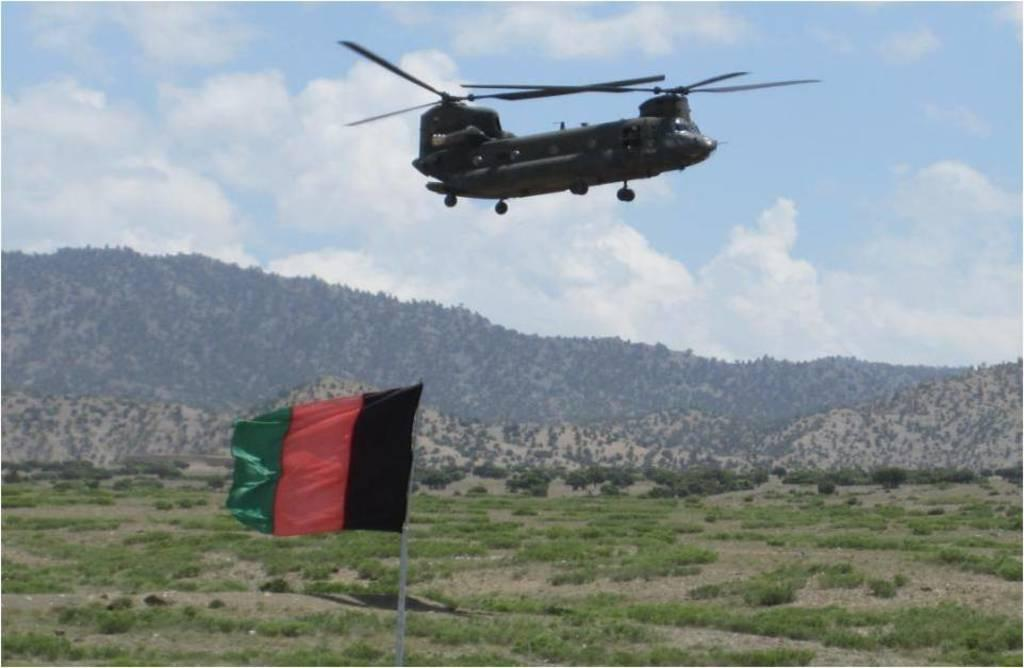What colors are present on the flag in the image? The flag in the image has black, red, and green colors. What can be seen in the background of the image? There is an aircraft and trees with green color in the background of the image. What is the color of the sky in the image? The sky is blue and white in the image. What type of disease is affecting the trees in the image? There is no indication of any disease affecting the trees in the image; they appear to be healthy with green leaves. How many boxes can be seen in the image? There are no boxes present in the image. 